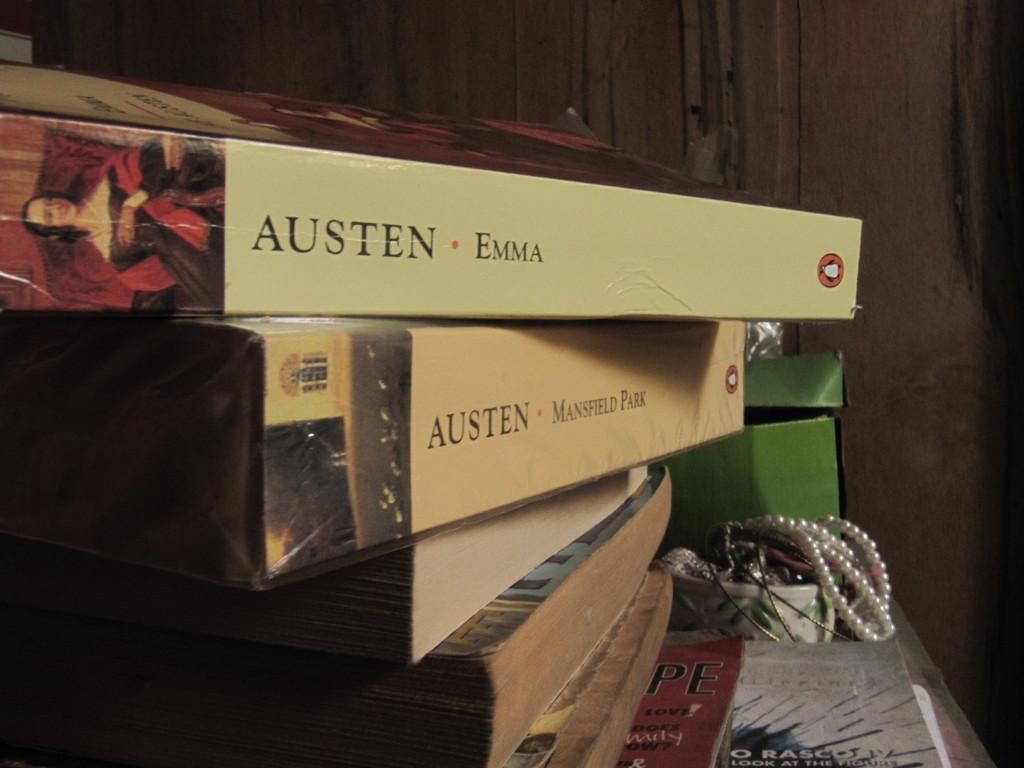Which book is that on top?
Offer a very short reply. Emma. Who wrote the top two books?
Keep it short and to the point. Austen. 